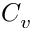Convert formula to latex. <formula><loc_0><loc_0><loc_500><loc_500>C _ { v }</formula> 